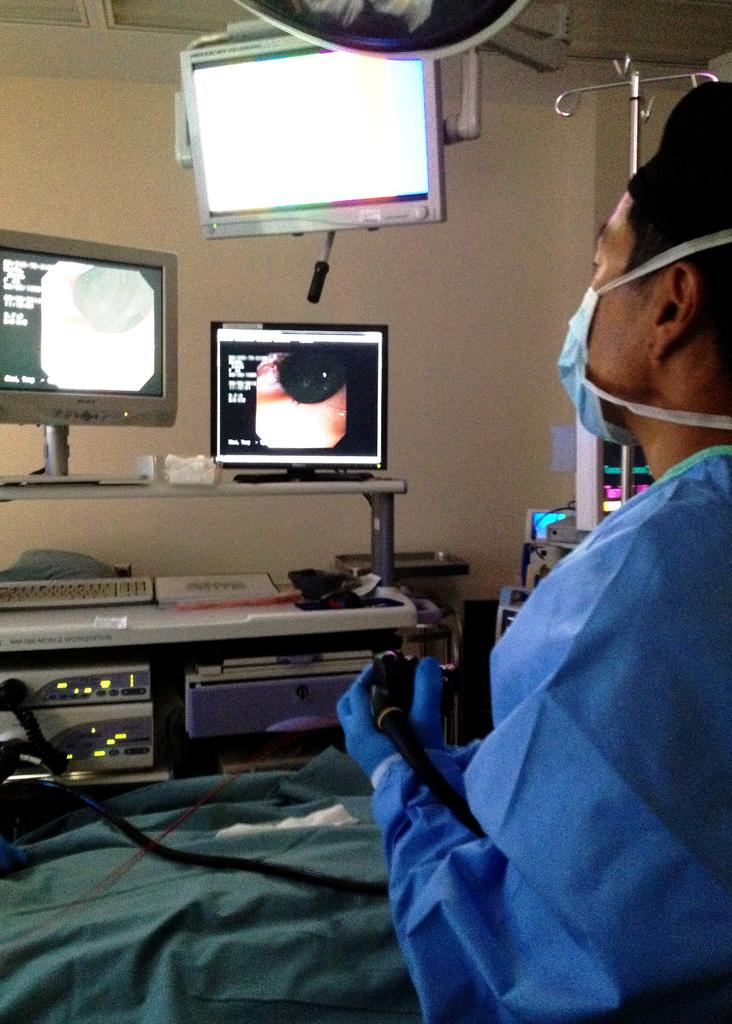What type of objects can be seen in the image? There are electronic devices in the image. Can you describe the person in the image? There is a person in the image. What is the person holding in his hand? The person is holding an object in his hand. What can be used to support or display items in the image? There is a stand in the image. What type of cabbage is being used as a pillow in the image? There is no cabbage present in the image, nor is there any reference to a pillow or sleeping. 